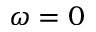<formula> <loc_0><loc_0><loc_500><loc_500>\omega = 0</formula> 